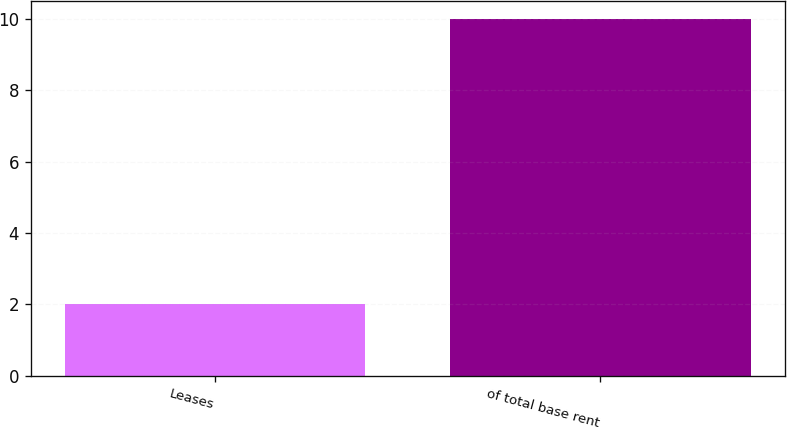Convert chart. <chart><loc_0><loc_0><loc_500><loc_500><bar_chart><fcel>Leases<fcel>of total base rent<nl><fcel>2<fcel>10<nl></chart> 